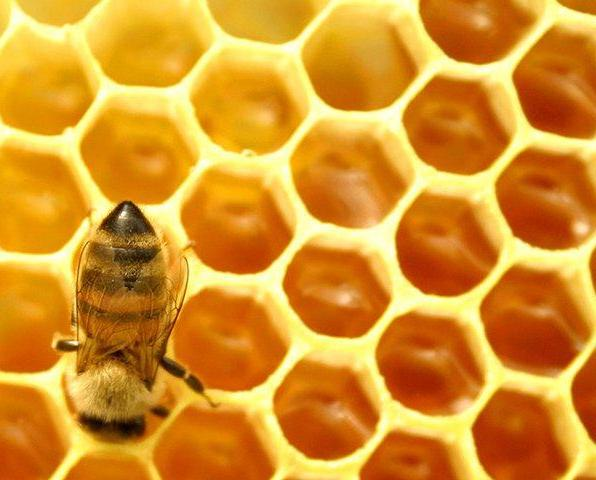Texture is defined as the feel, appearance or consistency of a surface or substance from a human's perspective. Detect the primary texture represented in the image. The primary texture in view is the intricate, waxy, smooth surface of the honeycomb meticulously crafted by bees from beeswax. The beeswax provides a slick, slightly sticky feel, adjusted precisely by the bees for optimal honey storage. Notice the interior gloss that shines under light, enhancing the visual texture of liquidity despite its solid form. Complementing this are the contrasting textures of the honeybee itself: its body boasts a fuzzy, soft covering ideal for pollen collection, while its iridescent wings introduce a paper-thin, fragile texture, creating a harmony of natural design and functionality. 